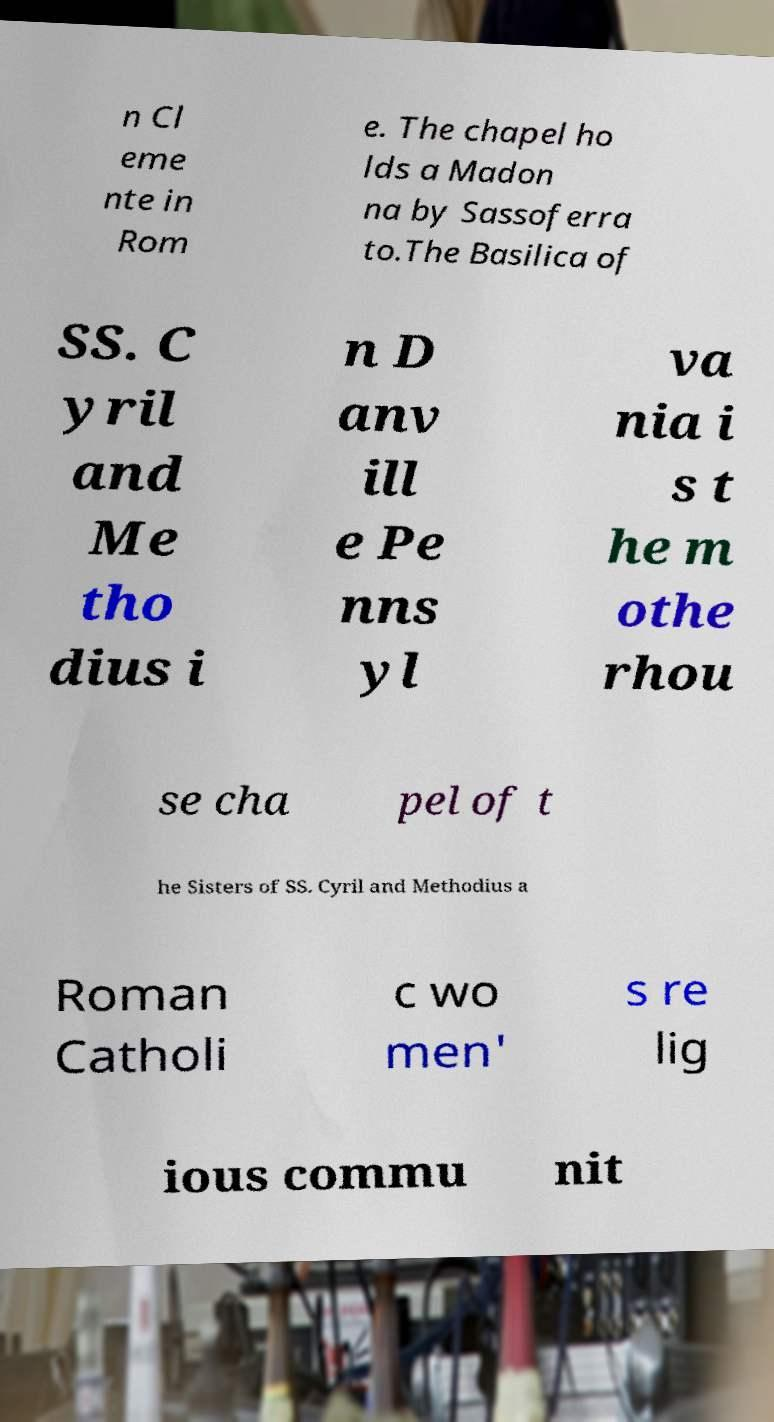Please identify and transcribe the text found in this image. n Cl eme nte in Rom e. The chapel ho lds a Madon na by Sassoferra to.The Basilica of SS. C yril and Me tho dius i n D anv ill e Pe nns yl va nia i s t he m othe rhou se cha pel of t he Sisters of SS. Cyril and Methodius a Roman Catholi c wo men' s re lig ious commu nit 